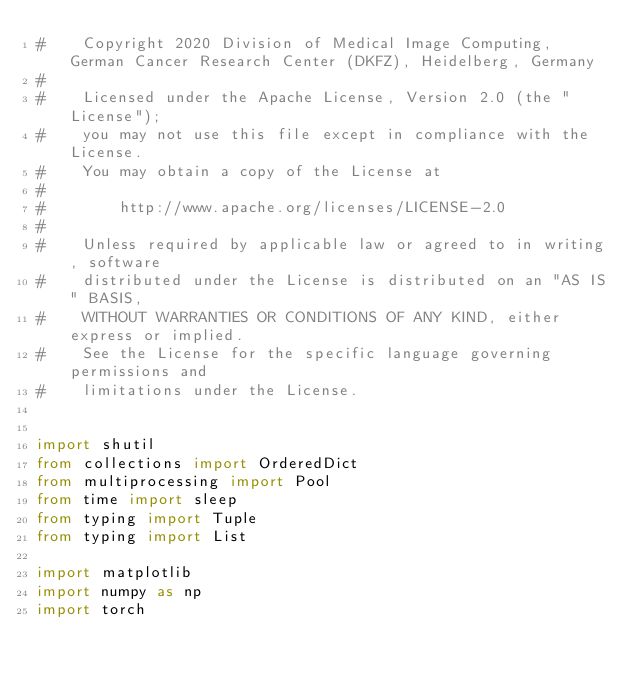<code> <loc_0><loc_0><loc_500><loc_500><_Python_>#    Copyright 2020 Division of Medical Image Computing, German Cancer Research Center (DKFZ), Heidelberg, Germany
#
#    Licensed under the Apache License, Version 2.0 (the "License");
#    you may not use this file except in compliance with the License.
#    You may obtain a copy of the License at
#
#        http://www.apache.org/licenses/LICENSE-2.0
#
#    Unless required by applicable law or agreed to in writing, software
#    distributed under the License is distributed on an "AS IS" BASIS,
#    WITHOUT WARRANTIES OR CONDITIONS OF ANY KIND, either express or implied.
#    See the License for the specific language governing permissions and
#    limitations under the License.


import shutil
from collections import OrderedDict
from multiprocessing import Pool
from time import sleep
from typing import Tuple
from typing import List

import matplotlib
import numpy as np
import torch</code> 